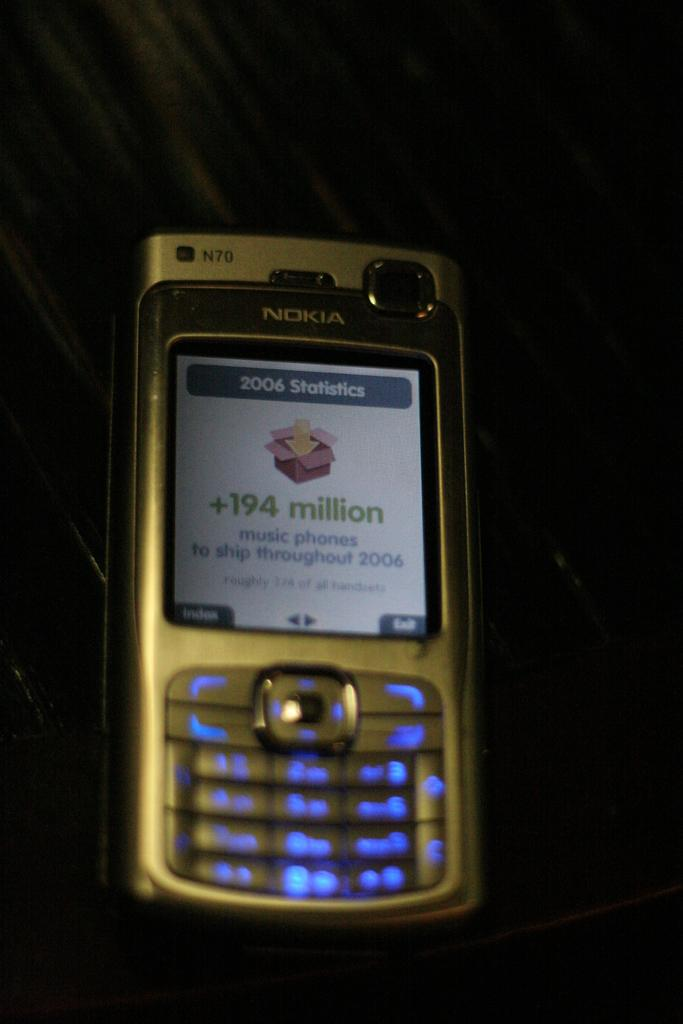<image>
Render a clear and concise summary of the photo. A phone has the model number N70 on the front of it in the corner. 